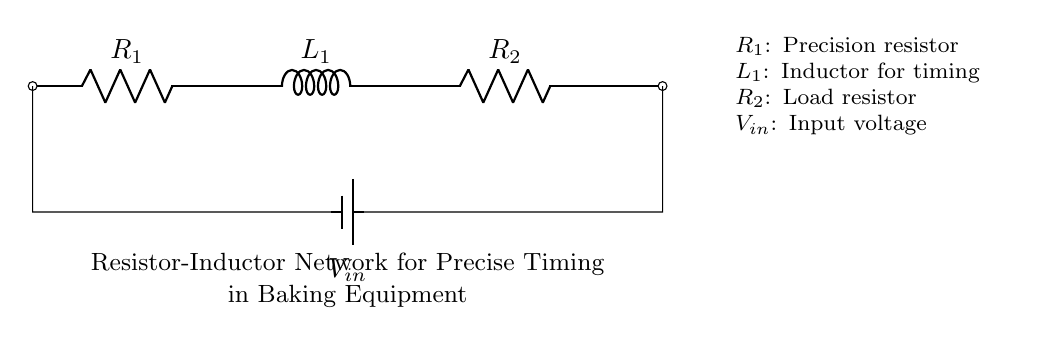What is the input voltage in the circuit? The circuit shows an input voltage labeled as V_in, which is the source of power for the circuit.
Answer: V_in What type of components are R1 and R2? R1 is a precision resistor and R2 is a load resistor, indicated by their labels in the circuit diagram.
Answer: Resistors What is the role of L1 in this circuit? L1 is an inductor, which is used for timing in the circuit, as specified in the description accompanying the diagram.
Answer: Timing How many resistors are present in the circuit? The visual indicates there are two resistors, R1 and R2, present in the network.
Answer: Two What is connected in series with L1? The circuit diagram shows that resistor R2 is connected in series with the inductor L1.
Answer: Resistor R2 What effect does the resistor-inductor network have on timing? The inductor in conjunction with the precision resistor allows for specific timing characteristics useful in baking equipment, combining resistance and inductance to create a time delay.
Answer: Timing characteristics What happens to current when L1 is energized? When energized, the inductor L1 will cause the current to change gradually, storing energy in its magnetic field, which influences the timing aspect of the circuit.
Answer: Gradual change in current 